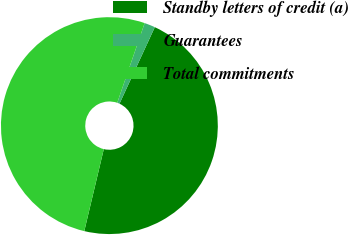<chart> <loc_0><loc_0><loc_500><loc_500><pie_chart><fcel>Standby letters of credit (a)<fcel>Guarantees<fcel>Total commitments<nl><fcel>46.84%<fcel>1.61%<fcel>51.55%<nl></chart> 